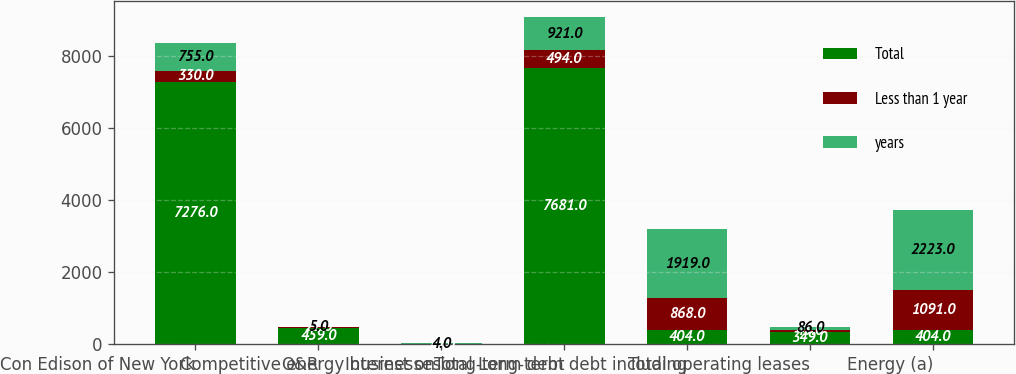<chart> <loc_0><loc_0><loc_500><loc_500><stacked_bar_chart><ecel><fcel>Con Edison of New York<fcel>O&R<fcel>Competitive energy businesses<fcel>Interest on long-term debt<fcel>Total Long-term debt including<fcel>Total operating leases<fcel>Energy (a)<nl><fcel>Total<fcel>7276<fcel>459<fcel>10<fcel>7681<fcel>404<fcel>349<fcel>404<nl><fcel>Less than 1 year<fcel>330<fcel>22<fcel>2<fcel>494<fcel>868<fcel>43<fcel>1091<nl><fcel>years<fcel>755<fcel>5<fcel>4<fcel>921<fcel>1919<fcel>86<fcel>2223<nl></chart> 